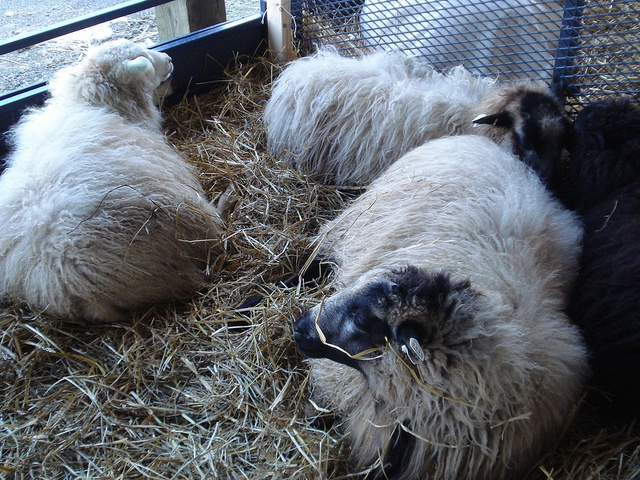Describe the objects in this image and their specific colors. I can see sheep in lightblue, gray, black, darkgray, and lightgray tones, sheep in lightblue, gray, darkgray, white, and black tones, sheep in lightblue, darkgray, gray, black, and lavender tones, and sheep in lightblue, black, navy, gray, and blue tones in this image. 